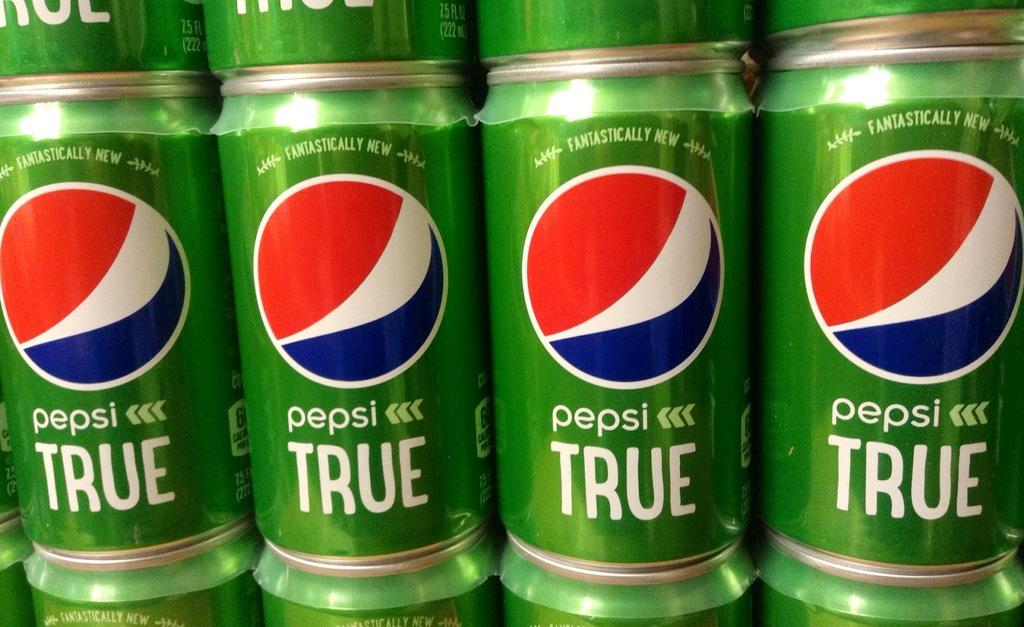Provide a one-sentence caption for the provided image. Several green cans of Pepsi TRUE are stack on top of each other. 